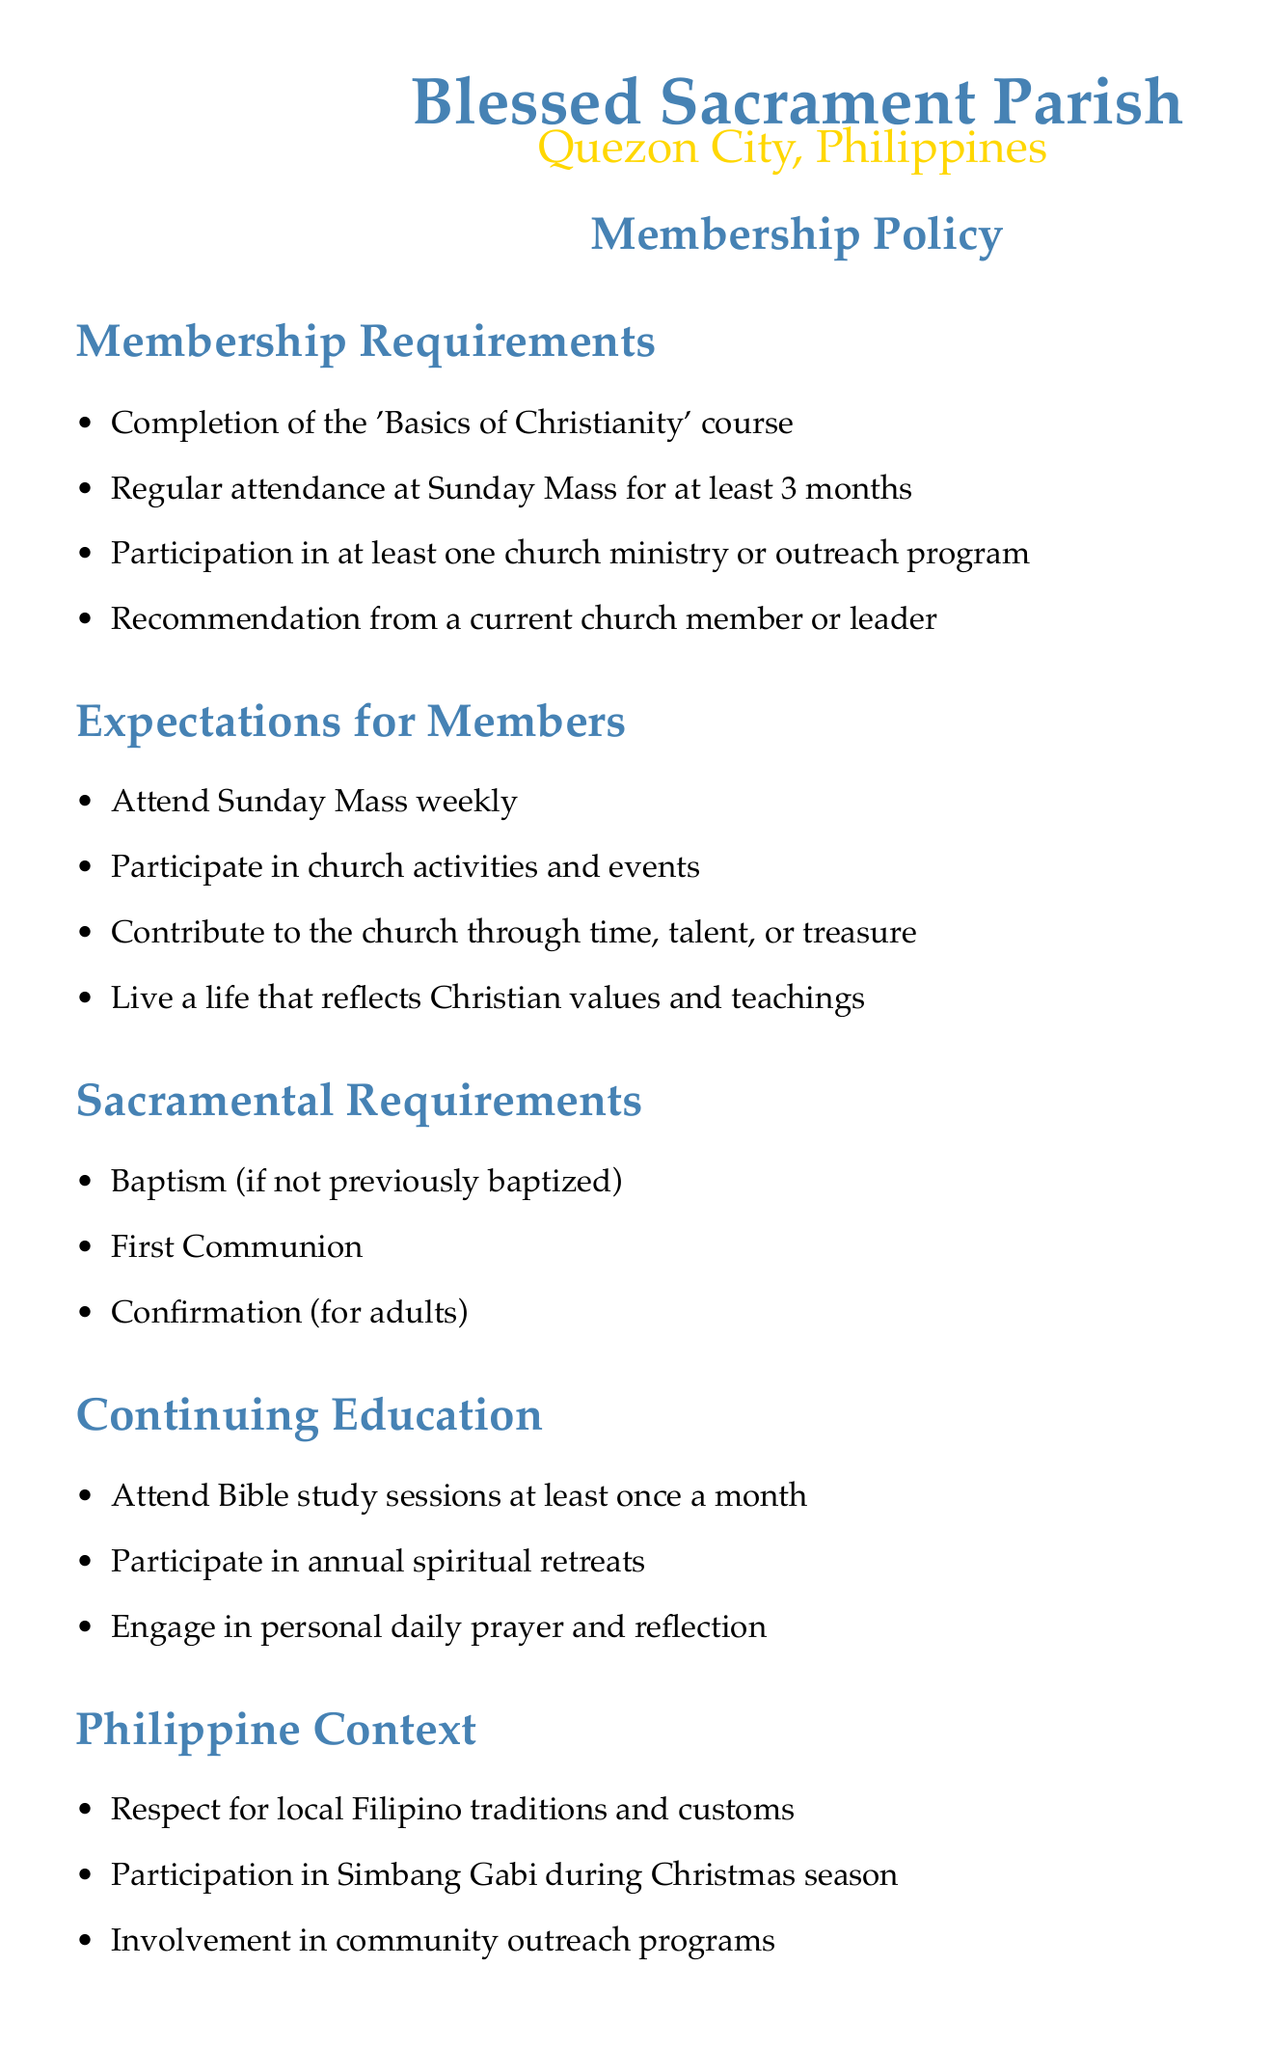What is the course required for membership? The document states that new converts must complete the 'Basics of Christianity' course as a requirement for membership.
Answer: 'Basics of Christianity' How long must a new member attend Sunday Mass? According to the policy, new members are expected to attend Sunday Mass regularly for at least 3 months.
Answer: 3 months What is one of the expectations for church members? The document outlines several expectations for members, one of which is to contribute to the church through time, talent, or treasure.
Answer: Contribute to the church What are the sacramental requirements for adults? The policy specifies that adults must receive Baptism, First Communion, and Confirmation as sacramental requirements.
Answer: Baptism, First Communion, Confirmation How often should members attend Bible study sessions? The document mentions that members should attend Bible study sessions at least once a month.
Answer: Once a month What cultural event should members participate in during the Christmas season? The policy document highlights the participation in Simbang Gabi as an important cultural event during the Christmas season.
Answer: Simbang Gabi What is a benefit of being a church member? Members are entitled to pastoral counseling as one of the benefits listed in the document.
Answer: Pastoral counseling How often does the membership review take place? The document states that there is an annual membership review with the parish priest or designated leader.
Answer: Annual 